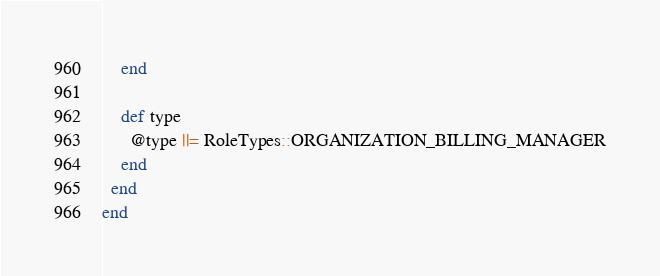<code> <loc_0><loc_0><loc_500><loc_500><_Ruby_>    end

    def type
      @type ||= RoleTypes::ORGANIZATION_BILLING_MANAGER
    end
  end
end
</code> 